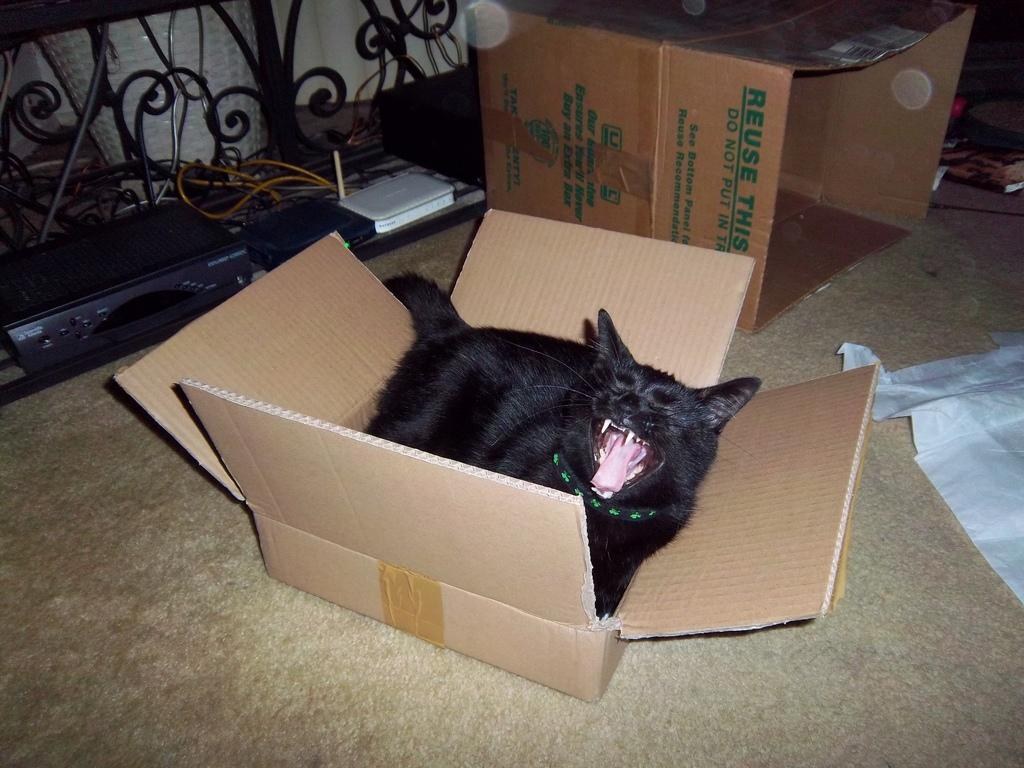<image>
Share a concise interpretation of the image provided. boxes on the ground with one of them labeled 'reuse this' 